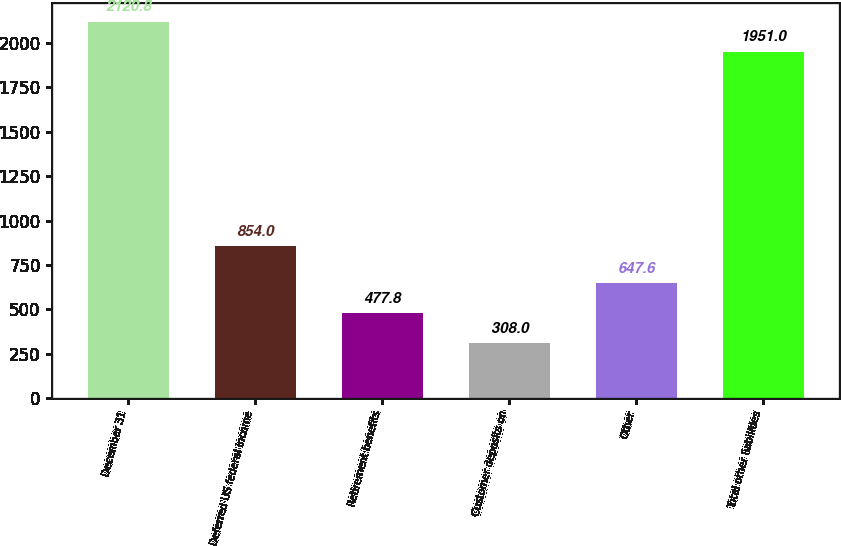Convert chart to OTSL. <chart><loc_0><loc_0><loc_500><loc_500><bar_chart><fcel>December 31<fcel>Deferred US federal income<fcel>Retirement benefits<fcel>Customer deposits on<fcel>Other<fcel>Total other liabilities<nl><fcel>2120.8<fcel>854<fcel>477.8<fcel>308<fcel>647.6<fcel>1951<nl></chart> 